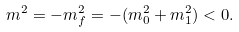Convert formula to latex. <formula><loc_0><loc_0><loc_500><loc_500>m ^ { 2 } = - m _ { f } ^ { 2 } = - ( m _ { 0 } ^ { 2 } + m _ { 1 } ^ { 2 } ) < 0 .</formula> 